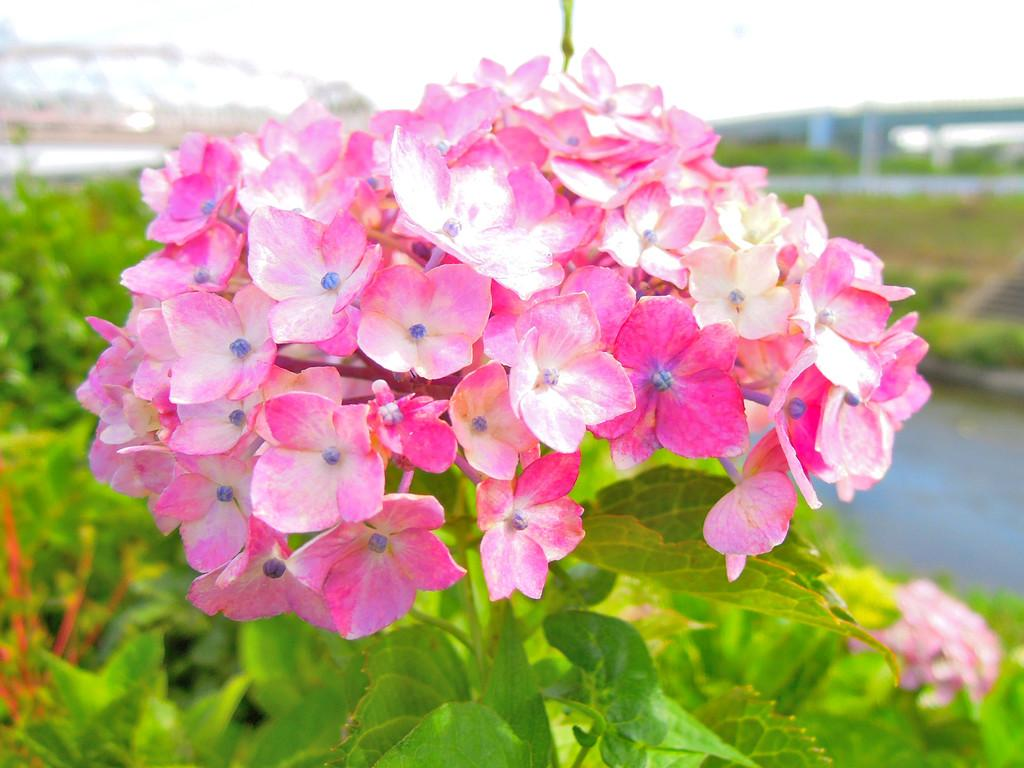What is the main subject of the picture? The main subject of the picture is a bunch of flowers. Can you describe the background of the image? The background of the image is blurry. Is there a snake slithering through the flowers in the image? No, there is no snake present in the image. Is the bunch of flowers hot to the touch in the image? The image does not provide information about the temperature of the flowers, so we cannot determine if they are hot or not. 